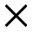<formula> <loc_0><loc_0><loc_500><loc_500>\times</formula> 